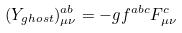<formula> <loc_0><loc_0><loc_500><loc_500>( Y _ { g h o s t } ) ^ { a b } _ { \mu \nu } = - g f ^ { a b c } F ^ { c } _ { \mu \nu }</formula> 